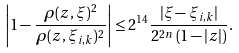Convert formula to latex. <formula><loc_0><loc_0><loc_500><loc_500>\left | 1 - \frac { \rho ( z , \xi ) ^ { 2 } } { \rho ( z , \xi _ { i , k } ) ^ { 2 } } \right | \leq 2 ^ { 1 4 } \frac { | \xi - \xi _ { i , k } | } { 2 ^ { 2 n } \left ( 1 - | z | \right ) } .</formula> 